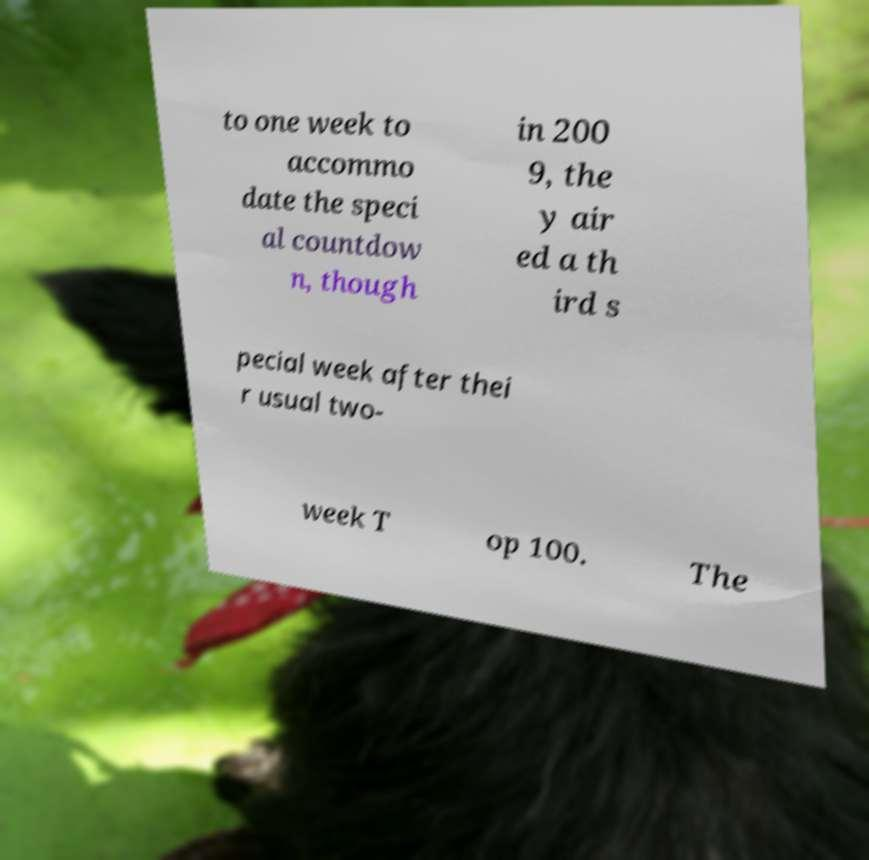For documentation purposes, I need the text within this image transcribed. Could you provide that? to one week to accommo date the speci al countdow n, though in 200 9, the y air ed a th ird s pecial week after thei r usual two- week T op 100. The 